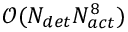Convert formula to latex. <formula><loc_0><loc_0><loc_500><loc_500>\mathcal { O } ( N _ { d e t } N _ { a c t } ^ { 8 } )</formula> 